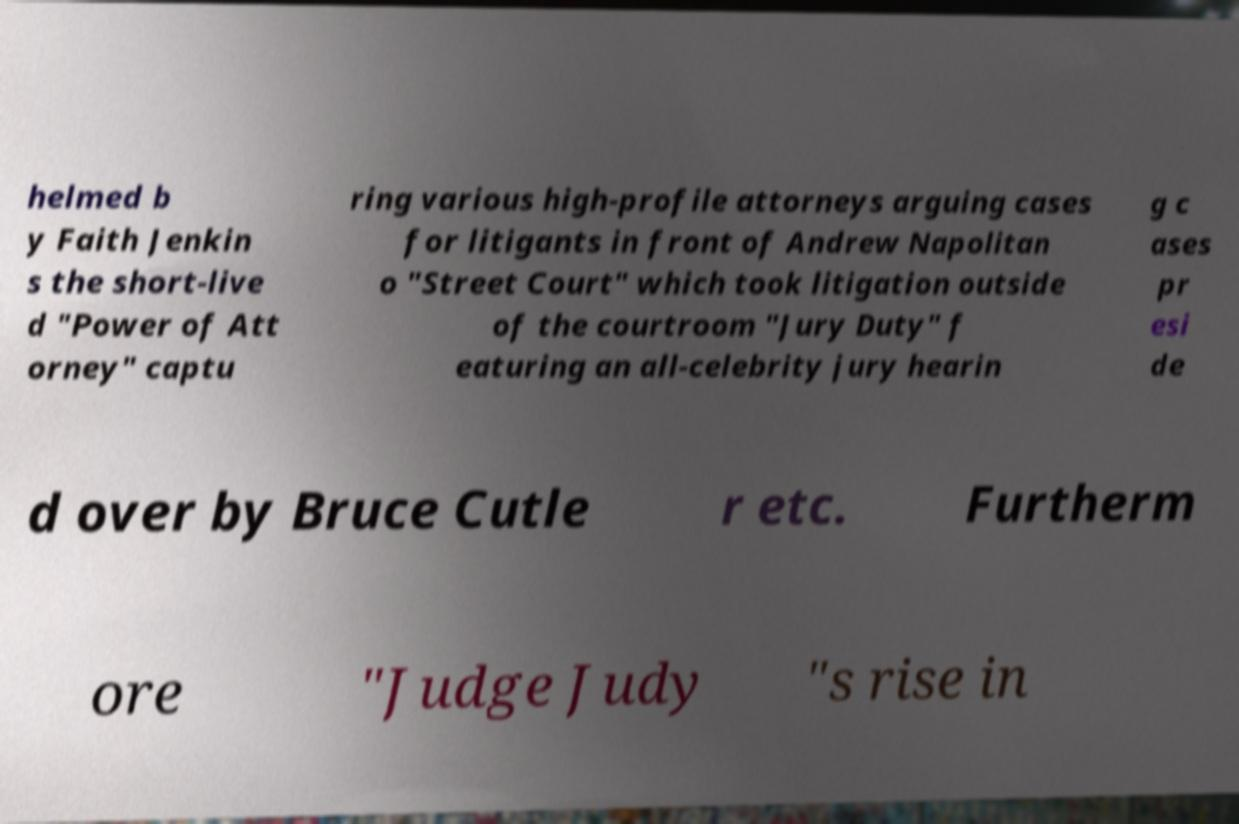Could you extract and type out the text from this image? helmed b y Faith Jenkin s the short-live d "Power of Att orney" captu ring various high-profile attorneys arguing cases for litigants in front of Andrew Napolitan o "Street Court" which took litigation outside of the courtroom "Jury Duty" f eaturing an all-celebrity jury hearin g c ases pr esi de d over by Bruce Cutle r etc. Furtherm ore "Judge Judy "s rise in 